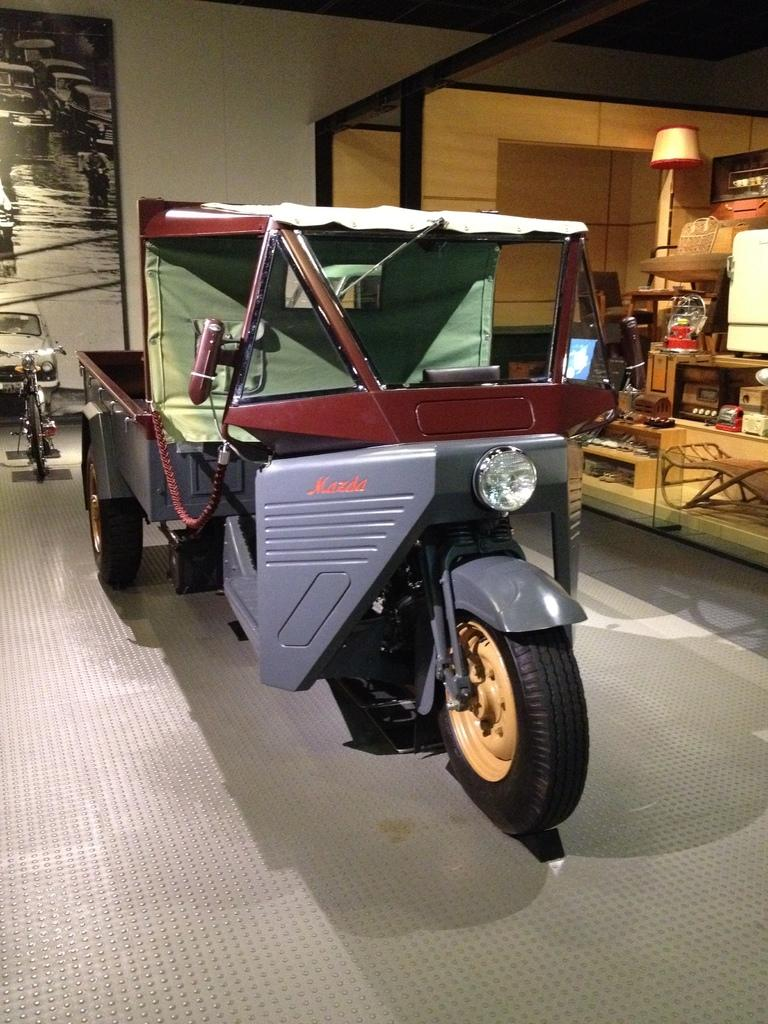What types of vehicles are in the image? There are vehicles in the image, but the specific types are not mentioned. What else can be seen in the image besides vehicles? There are bags and a lamp visible in the image. What other objects can be seen in the image? There are other objects in the image, but their specific details are not mentioned. What is visible in the background of the image? There is a board and a wall in the background of the image. What type of plane can be seen flying in the image? There is no plane visible in the image. 